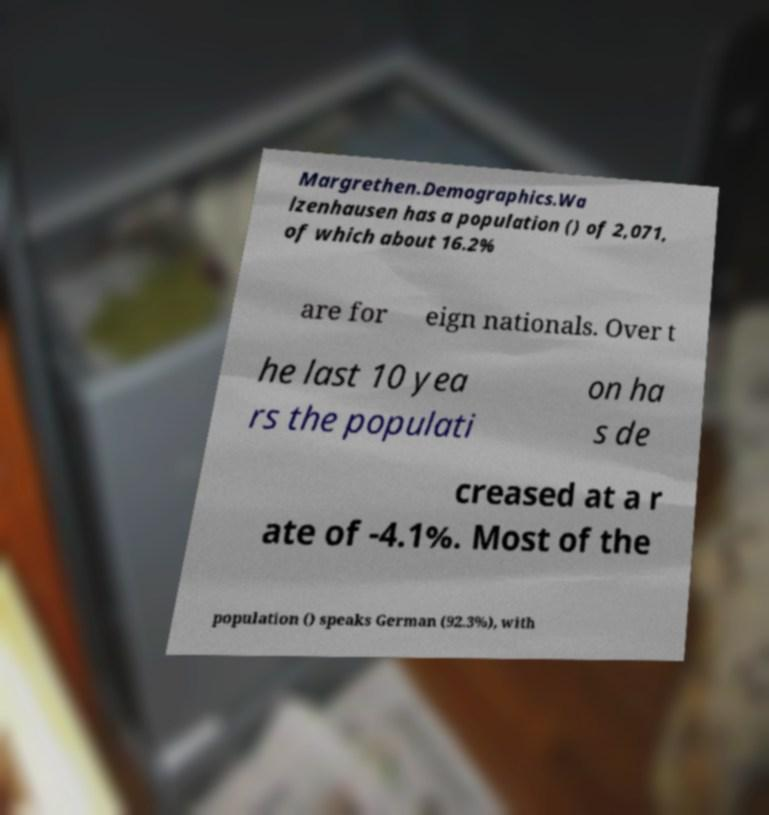I need the written content from this picture converted into text. Can you do that? Margrethen.Demographics.Wa lzenhausen has a population () of 2,071, of which about 16.2% are for eign nationals. Over t he last 10 yea rs the populati on ha s de creased at a r ate of -4.1%. Most of the population () speaks German (92.3%), with 